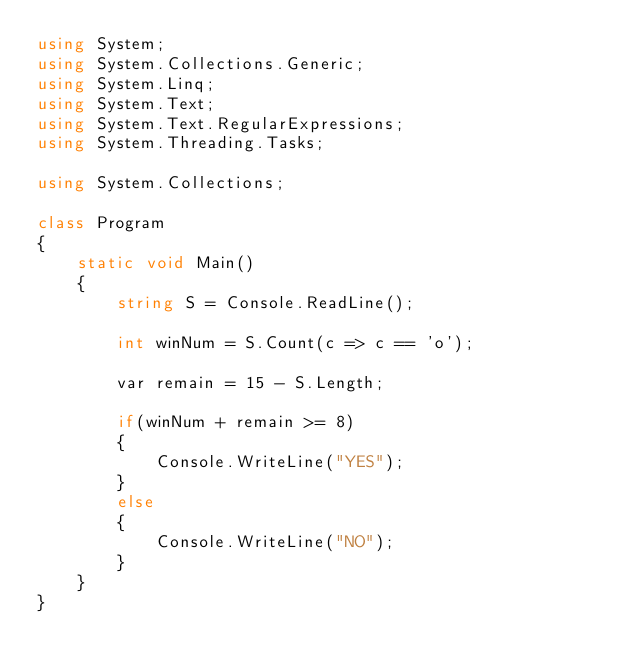Convert code to text. <code><loc_0><loc_0><loc_500><loc_500><_C#_>using System;
using System.Collections.Generic;
using System.Linq;
using System.Text;
using System.Text.RegularExpressions;
using System.Threading.Tasks;

using System.Collections;

class Program
{
    static void Main()
    {
        string S = Console.ReadLine();

        int winNum = S.Count(c => c == 'o');

        var remain = 15 - S.Length;

        if(winNum + remain >= 8)
        {
            Console.WriteLine("YES");
        }
        else
        {
            Console.WriteLine("NO");
        }
    }
}
</code> 